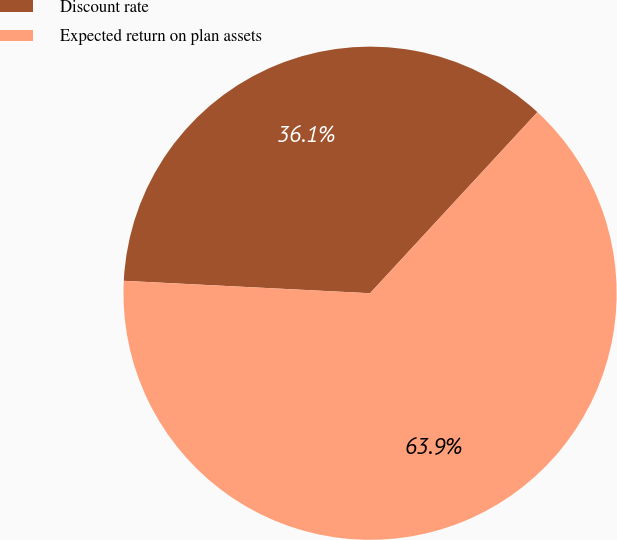Convert chart. <chart><loc_0><loc_0><loc_500><loc_500><pie_chart><fcel>Discount rate<fcel>Expected return on plan assets<nl><fcel>36.07%<fcel>63.93%<nl></chart> 